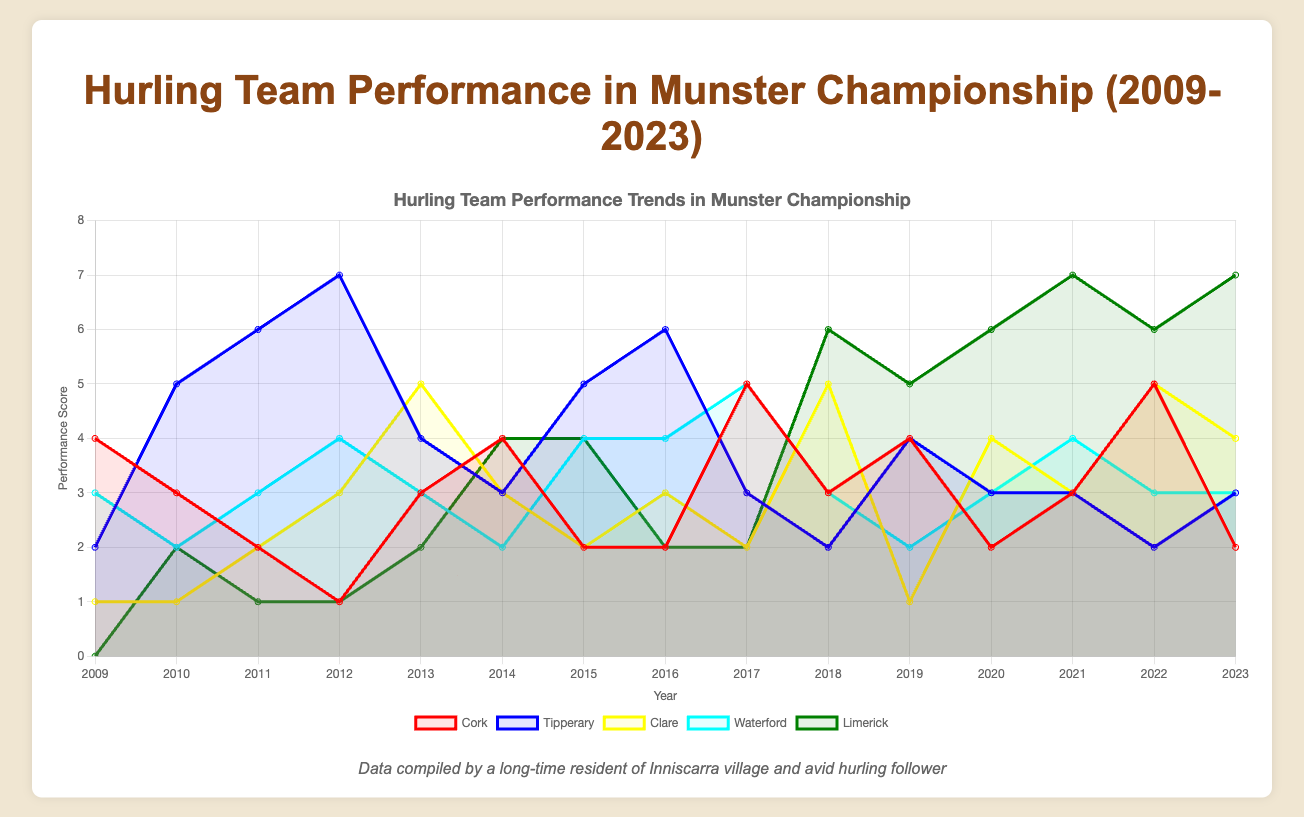What is the title of the chart? The title of the chart is displayed at the top and is intended to describe the main topic of the chart. In this case, it provides an overview of what the chart is about.
Answer: Hurling Team Performance in Munster Championship (2009-2023) What are the axes labeled in the chart? The chart typically has two axes, one representing the categories (usually years) and the other representing the values (performance scores). In this chart, the x-axis shows the years from 2009 to 2023, and the y-axis shows the performance scores ranging from 0 to 8.
Answer: Years and Performance Score Which team had the highest performance score in 2016? To find this, look at the values for each team's dataset in the year 2016. Compare the values visually or by looking at the point markers.
Answer: Tipperary In which year did Cork have its highest performance score? Scan through the dataset for Cork's values across all years and identify the highest value. Then, look at the corresponding year for this value.
Answer: 2017 Which team showed the most consistent performance from 2019 to 2021? To determine consistency, examine the lines or areas on the chart for each team between 2019 and 2021. Look for the team whose performance scores change the least during these years.
Answer: Limerick What is the sum of Clare's performance scores in 2010 and 2012? Look at Clare's values for the years 2010 and 2012 and add them together.
Answer: 4 Compare Cork's performance in 2009 and 2023. Did it improve or decline? Visually compare the performance scores of Cork in the years 2009 and 2023. Identify if the value increased or decreased.
Answer: Decline Which team had the lowest performance score in the entire timeline? Review the values for each team's performance for all years and identify the lowest score. Determine which team and year this score occurred.
Answer: Limerick in 2009 What was the average performance score for Waterford between 2014 and 2018? Sum Waterford's scores for the years 2014, 2015, 2016, 2017, and 2018, and then divide by the number of years (5).
Answer: 3.4 